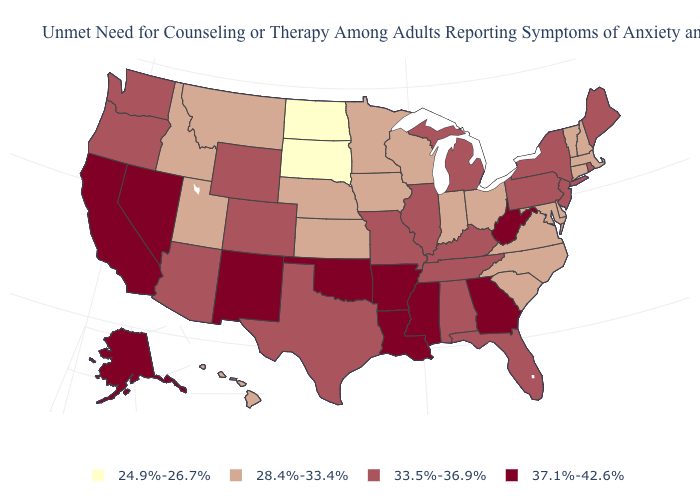Which states hav the highest value in the MidWest?
Be succinct. Illinois, Michigan, Missouri. What is the value of Louisiana?
Quick response, please. 37.1%-42.6%. What is the lowest value in the USA?
Be succinct. 24.9%-26.7%. Does North Dakota have the lowest value in the USA?
Keep it brief. Yes. What is the value of Indiana?
Write a very short answer. 28.4%-33.4%. What is the lowest value in states that border Connecticut?
Be succinct. 28.4%-33.4%. How many symbols are there in the legend?
Quick response, please. 4. What is the value of Tennessee?
Short answer required. 33.5%-36.9%. Among the states that border Kansas , which have the highest value?
Be succinct. Oklahoma. What is the value of Oregon?
Concise answer only. 33.5%-36.9%. Does Kentucky have the same value as South Carolina?
Give a very brief answer. No. What is the value of Arkansas?
Keep it brief. 37.1%-42.6%. What is the value of Alabama?
Answer briefly. 33.5%-36.9%. What is the value of Michigan?
Be succinct. 33.5%-36.9%. Name the states that have a value in the range 37.1%-42.6%?
Write a very short answer. Alaska, Arkansas, California, Georgia, Louisiana, Mississippi, Nevada, New Mexico, Oklahoma, West Virginia. 